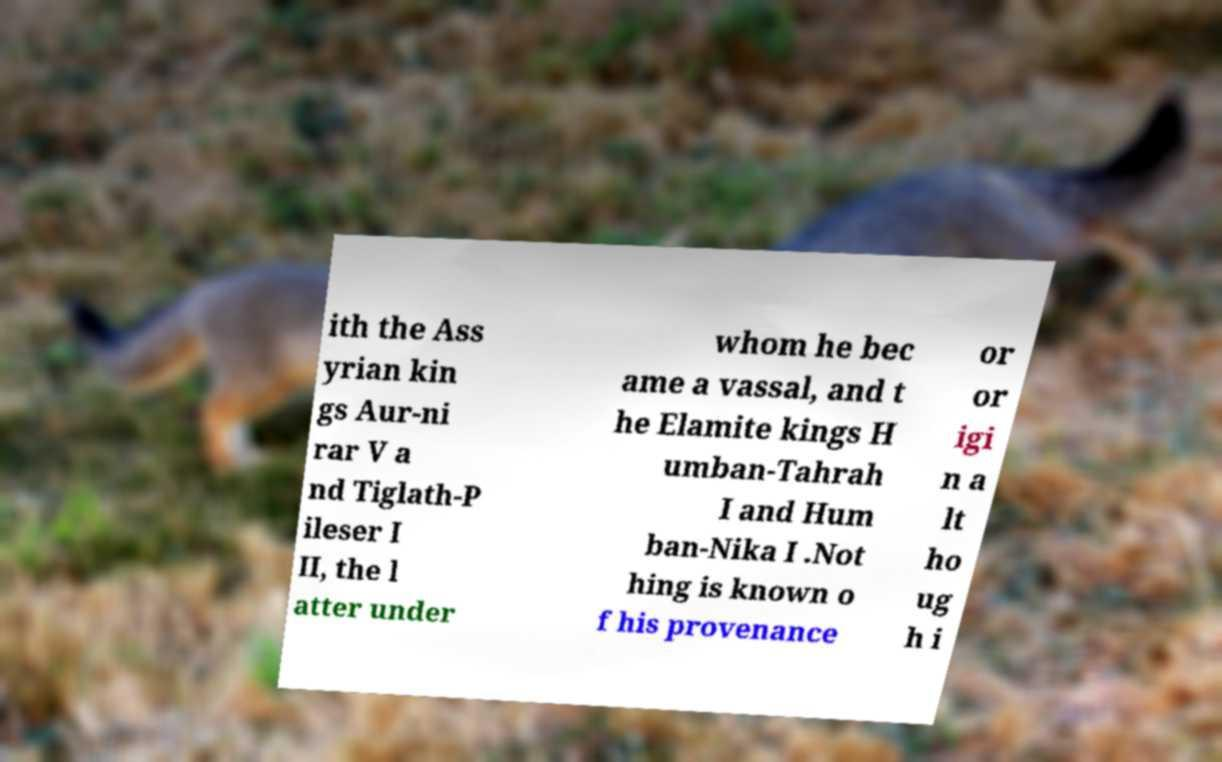There's text embedded in this image that I need extracted. Can you transcribe it verbatim? ith the Ass yrian kin gs Aur-ni rar V a nd Tiglath-P ileser I II, the l atter under whom he bec ame a vassal, and t he Elamite kings H umban-Tahrah I and Hum ban-Nika I .Not hing is known o f his provenance or or igi n a lt ho ug h i 